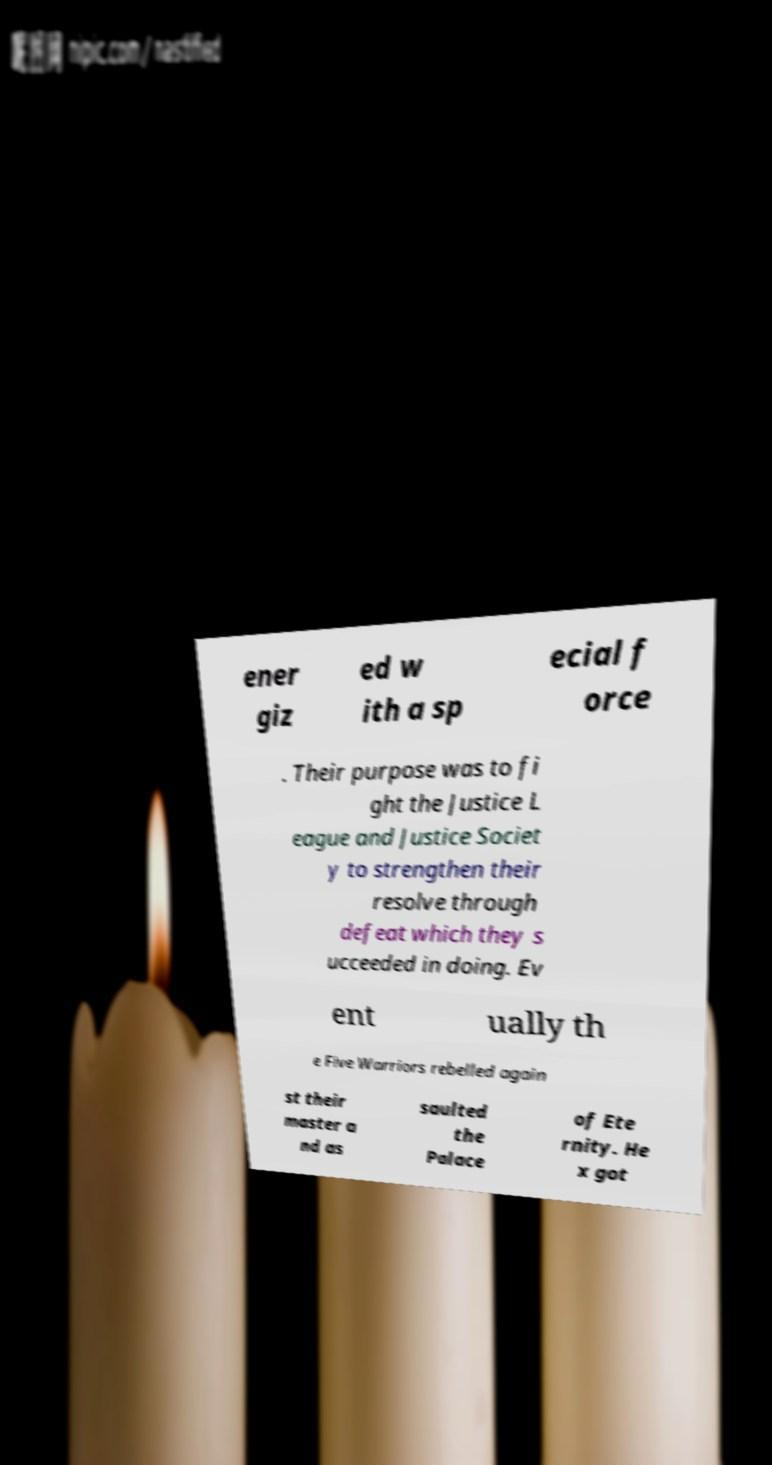What messages or text are displayed in this image? I need them in a readable, typed format. ener giz ed w ith a sp ecial f orce . Their purpose was to fi ght the Justice L eague and Justice Societ y to strengthen their resolve through defeat which they s ucceeded in doing. Ev ent ually th e Five Warriors rebelled again st their master a nd as saulted the Palace of Ete rnity. He x got 